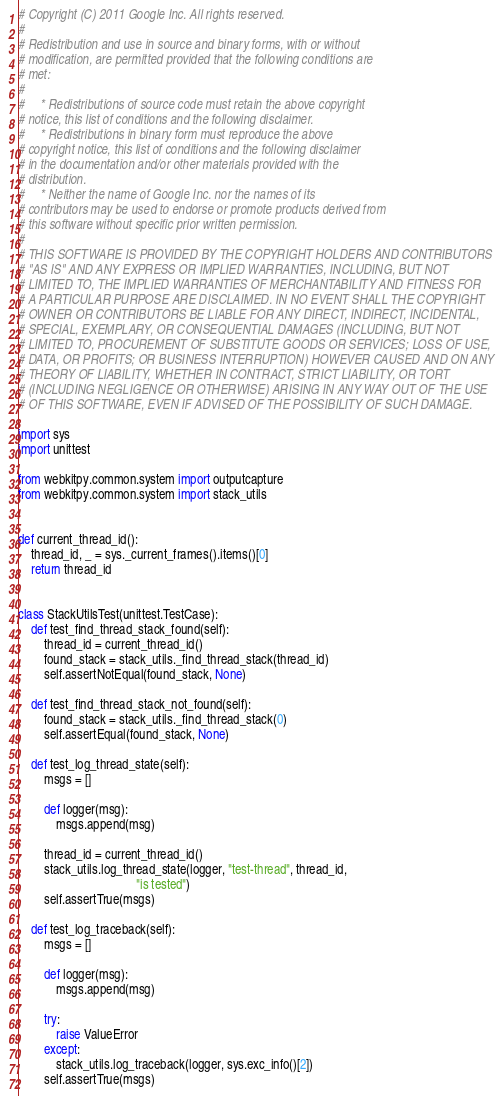Convert code to text. <code><loc_0><loc_0><loc_500><loc_500><_Python_># Copyright (C) 2011 Google Inc. All rights reserved.
#
# Redistribution and use in source and binary forms, with or without
# modification, are permitted provided that the following conditions are
# met:
#
#     * Redistributions of source code must retain the above copyright
# notice, this list of conditions and the following disclaimer.
#     * Redistributions in binary form must reproduce the above
# copyright notice, this list of conditions and the following disclaimer
# in the documentation and/or other materials provided with the
# distribution.
#     * Neither the name of Google Inc. nor the names of its
# contributors may be used to endorse or promote products derived from
# this software without specific prior written permission.
#
# THIS SOFTWARE IS PROVIDED BY THE COPYRIGHT HOLDERS AND CONTRIBUTORS
# "AS IS" AND ANY EXPRESS OR IMPLIED WARRANTIES, INCLUDING, BUT NOT
# LIMITED TO, THE IMPLIED WARRANTIES OF MERCHANTABILITY AND FITNESS FOR
# A PARTICULAR PURPOSE ARE DISCLAIMED. IN NO EVENT SHALL THE COPYRIGHT
# OWNER OR CONTRIBUTORS BE LIABLE FOR ANY DIRECT, INDIRECT, INCIDENTAL,
# SPECIAL, EXEMPLARY, OR CONSEQUENTIAL DAMAGES (INCLUDING, BUT NOT
# LIMITED TO, PROCUREMENT OF SUBSTITUTE GOODS OR SERVICES; LOSS OF USE,
# DATA, OR PROFITS; OR BUSINESS INTERRUPTION) HOWEVER CAUSED AND ON ANY
# THEORY OF LIABILITY, WHETHER IN CONTRACT, STRICT LIABILITY, OR TORT
# (INCLUDING NEGLIGENCE OR OTHERWISE) ARISING IN ANY WAY OUT OF THE USE
# OF THIS SOFTWARE, EVEN IF ADVISED OF THE POSSIBILITY OF SUCH DAMAGE.

import sys
import unittest

from webkitpy.common.system import outputcapture
from webkitpy.common.system import stack_utils


def current_thread_id():
    thread_id, _ = sys._current_frames().items()[0]
    return thread_id


class StackUtilsTest(unittest.TestCase):
    def test_find_thread_stack_found(self):
        thread_id = current_thread_id()
        found_stack = stack_utils._find_thread_stack(thread_id)
        self.assertNotEqual(found_stack, None)

    def test_find_thread_stack_not_found(self):
        found_stack = stack_utils._find_thread_stack(0)
        self.assertEqual(found_stack, None)

    def test_log_thread_state(self):
        msgs = []

        def logger(msg):
            msgs.append(msg)

        thread_id = current_thread_id()
        stack_utils.log_thread_state(logger, "test-thread", thread_id,
                                     "is tested")
        self.assertTrue(msgs)

    def test_log_traceback(self):
        msgs = []

        def logger(msg):
            msgs.append(msg)

        try:
            raise ValueError
        except:
            stack_utils.log_traceback(logger, sys.exc_info()[2])
        self.assertTrue(msgs)
</code> 